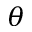<formula> <loc_0><loc_0><loc_500><loc_500>\theta</formula> 